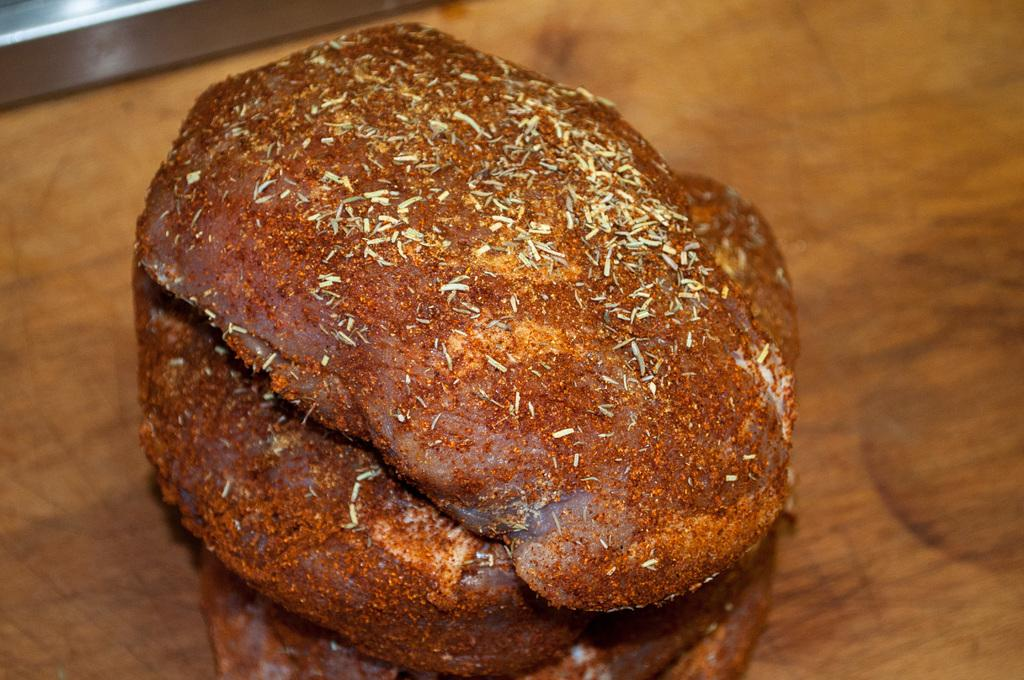What type of food can be seen on the table in the image? There is meat on the table in the image. What type of note is attached to the meat in the image? There is no note attached to the meat in the image. What type of cloth is covering the meat in the image? There is no cloth covering the meat in the image. 